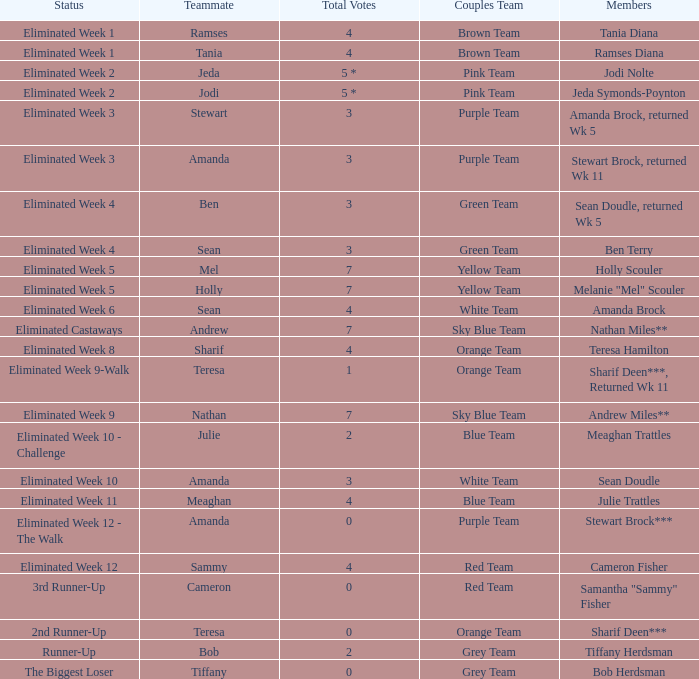Who had 0 total votes in the purple team? Eliminated Week 12 - The Walk. 